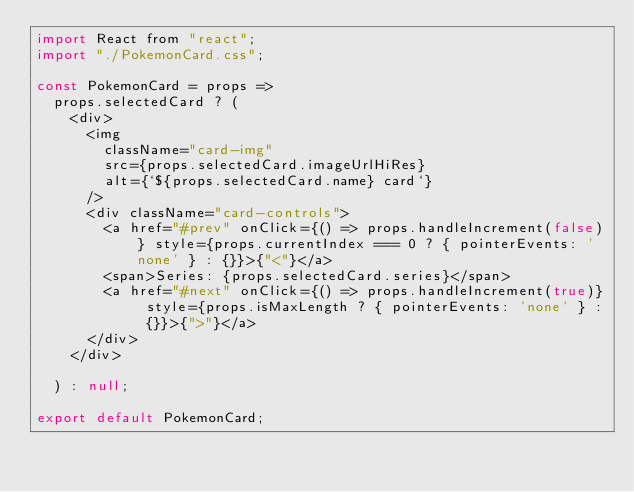Convert code to text. <code><loc_0><loc_0><loc_500><loc_500><_JavaScript_>import React from "react";
import "./PokemonCard.css";

const PokemonCard = props =>
  props.selectedCard ? (
    <div>
      <img
        className="card-img"
        src={props.selectedCard.imageUrlHiRes}
        alt={`${props.selectedCard.name} card`}
      />
      <div className="card-controls">
        <a href="#prev" onClick={() => props.handleIncrement(false)} style={props.currentIndex === 0 ? { pointerEvents: 'none' } : {}}>{"<"}</a>
        <span>Series: {props.selectedCard.series}</span>
        <a href="#next" onClick={() => props.handleIncrement(true)} style={props.isMaxLength ? { pointerEvents: 'none' } : {}}>{">"}</a>
      </div>
    </div>
    
  ) : null;

export default PokemonCard;
</code> 